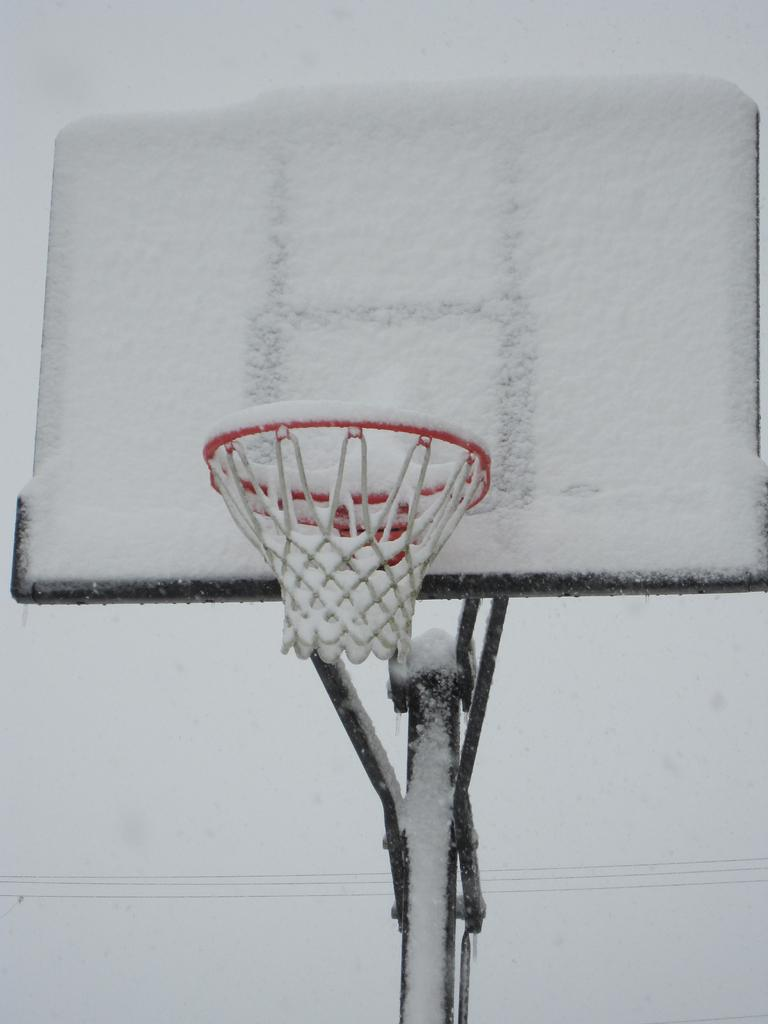What is the main object in the center of the image? There is a basketball pole in the center of the image. What is covering the basketball pole? There is snow on the basketball pole. What can be seen in the background of the image? There appear to be wires in the background of the image. Can you tell me how many mountains are visible in the image? There are no mountains visible in the image; it features a basketball pole with snow and wires in the background. What type of uncle is standing near the basketball pole? There is no uncle present in the image; it only shows a basketball pole with snow and wires in the background. 